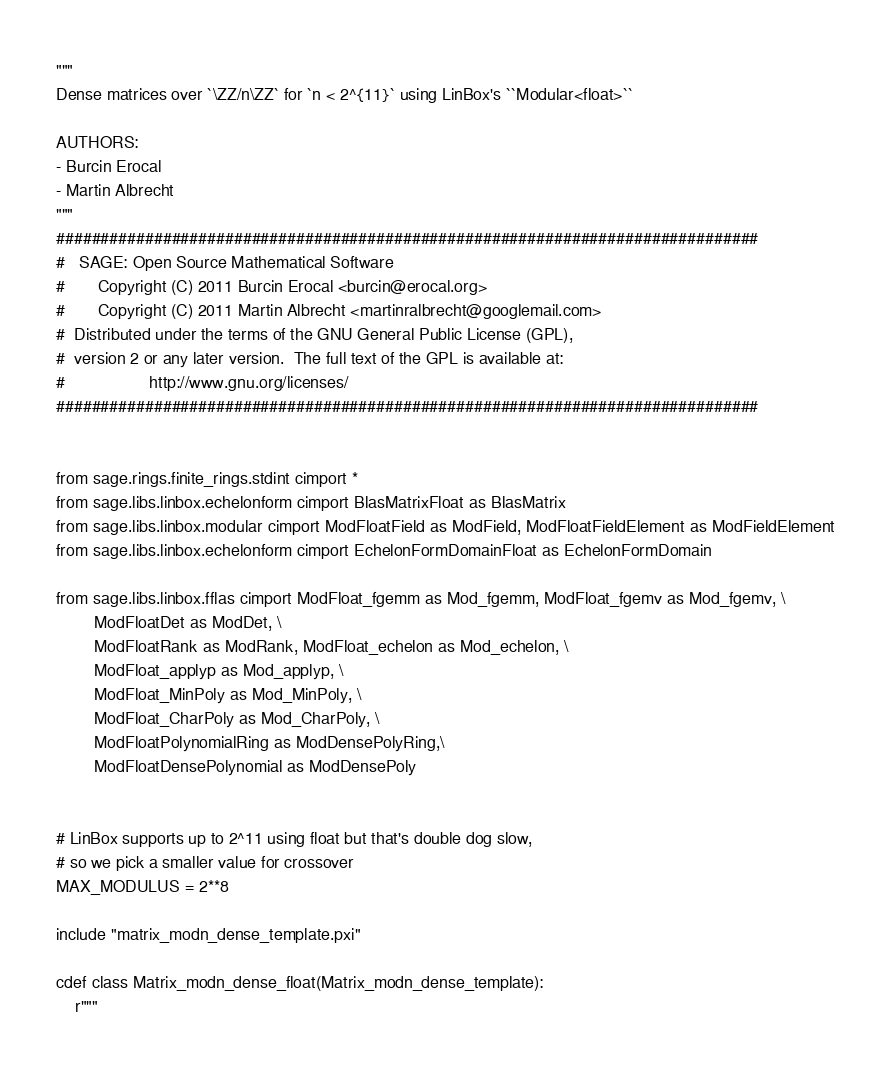Convert code to text. <code><loc_0><loc_0><loc_500><loc_500><_Cython_>"""
Dense matrices over `\ZZ/n\ZZ` for `n < 2^{11}` using LinBox's ``Modular<float>``

AUTHORS:
- Burcin Erocal
- Martin Albrecht
"""
###############################################################################
#   SAGE: Open Source Mathematical Software
#       Copyright (C) 2011 Burcin Erocal <burcin@erocal.org>
#       Copyright (C) 2011 Martin Albrecht <martinralbrecht@googlemail.com>
#  Distributed under the terms of the GNU General Public License (GPL),
#  version 2 or any later version.  The full text of the GPL is available at:
#                  http://www.gnu.org/licenses/
###############################################################################


from sage.rings.finite_rings.stdint cimport *
from sage.libs.linbox.echelonform cimport BlasMatrixFloat as BlasMatrix
from sage.libs.linbox.modular cimport ModFloatField as ModField, ModFloatFieldElement as ModFieldElement
from sage.libs.linbox.echelonform cimport EchelonFormDomainFloat as EchelonFormDomain

from sage.libs.linbox.fflas cimport ModFloat_fgemm as Mod_fgemm, ModFloat_fgemv as Mod_fgemv, \
        ModFloatDet as ModDet, \
        ModFloatRank as ModRank, ModFloat_echelon as Mod_echelon, \
        ModFloat_applyp as Mod_applyp, \
        ModFloat_MinPoly as Mod_MinPoly, \
        ModFloat_CharPoly as Mod_CharPoly, \
        ModFloatPolynomialRing as ModDensePolyRing,\
        ModFloatDensePolynomial as ModDensePoly


# LinBox supports up to 2^11 using float but that's double dog slow,
# so we pick a smaller value for crossover
MAX_MODULUS = 2**8

include "matrix_modn_dense_template.pxi"

cdef class Matrix_modn_dense_float(Matrix_modn_dense_template):
    r"""</code> 